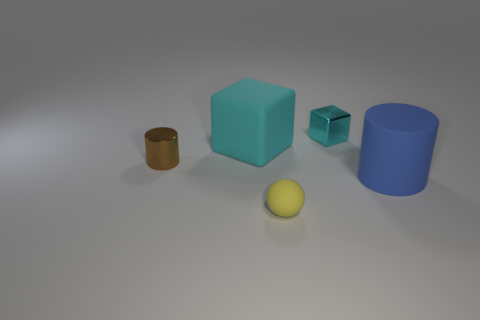Add 1 small brown metallic objects. How many objects exist? 6 Subtract all balls. How many objects are left? 4 Subtract all brown cubes. Subtract all blue spheres. How many cubes are left? 2 Subtract all brown balls. How many brown cylinders are left? 1 Subtract all big brown spheres. Subtract all small yellow matte spheres. How many objects are left? 4 Add 2 large cyan cubes. How many large cyan cubes are left? 3 Add 4 tiny shiny blocks. How many tiny shiny blocks exist? 5 Subtract all brown cylinders. How many cylinders are left? 1 Subtract 0 blue balls. How many objects are left? 5 